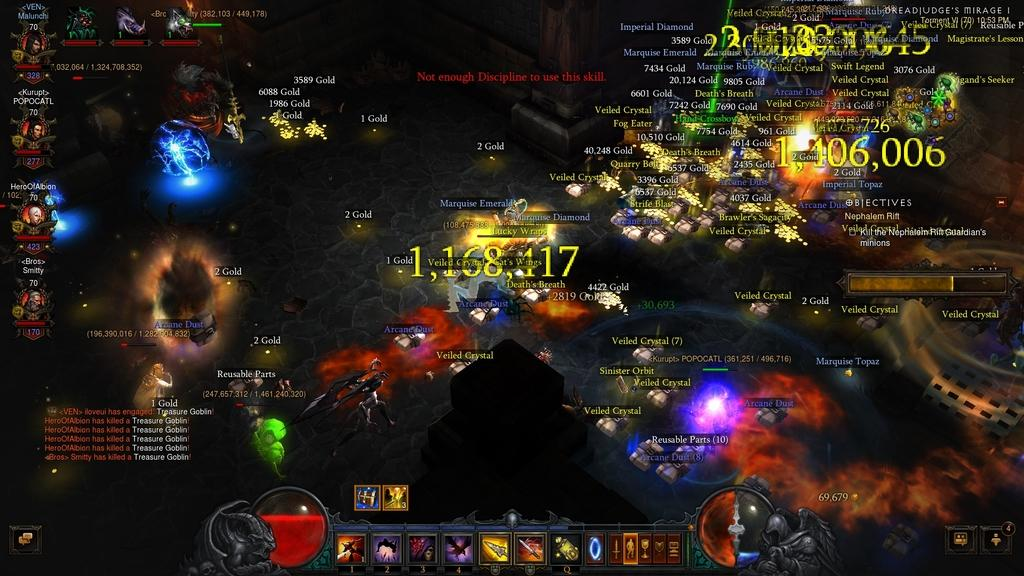What type of image is shown in the screenshot? The image is a screenshot of a game. What elements can be seen in the screenshot? The screenshot contains text and numbers. How would you describe the appearance of the image? The image is colorful. What category does the image fall under? The image is a form of digital art. What type of shirt is the character wearing in the image? There is no character or shirt present in the image, as it is a screenshot of a game that contains text and numbers. 